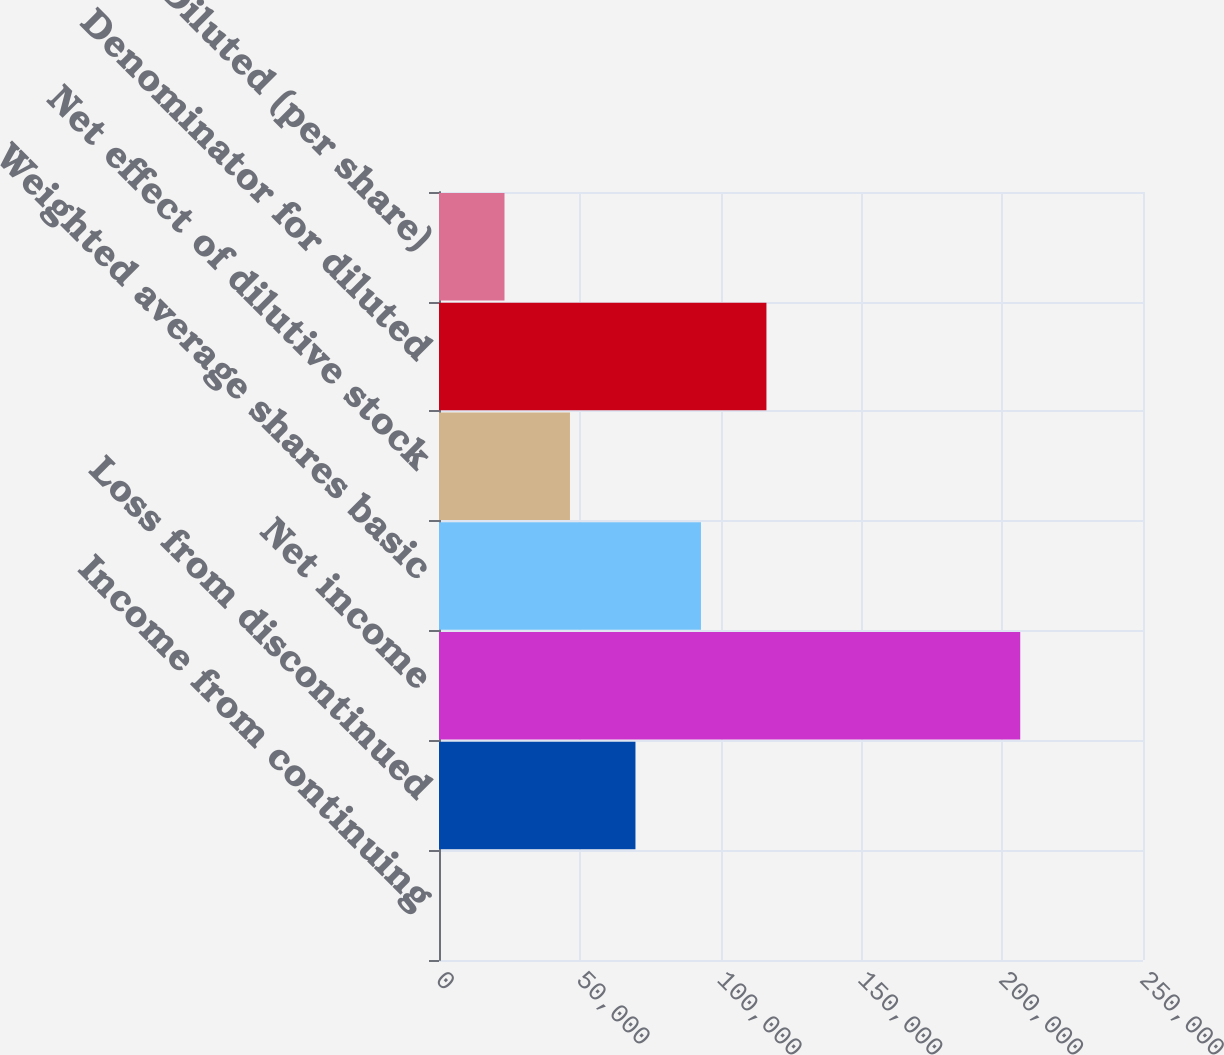Convert chart to OTSL. <chart><loc_0><loc_0><loc_500><loc_500><bar_chart><fcel>Income from continuing<fcel>Loss from discontinued<fcel>Net income<fcel>Weighted average shares basic<fcel>Net effect of dilutive stock<fcel>Denominator for diluted<fcel>Diluted (per share)<nl><fcel>0.36<fcel>69765.8<fcel>206402<fcel>93021<fcel>46510.7<fcel>116276<fcel>23255.5<nl></chart> 